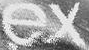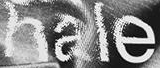Read the text content from these images in order, separated by a semicolon. ex; hale 